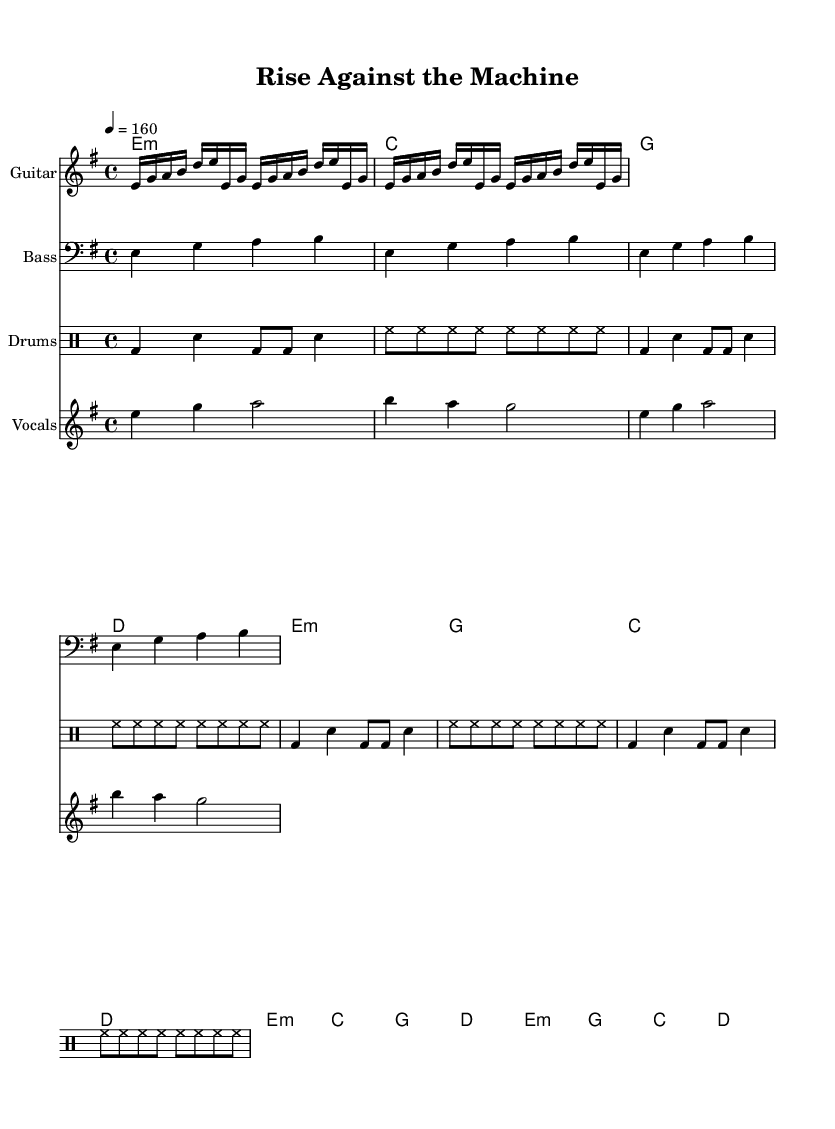What is the key signature of this music? The key signature is E minor, which has one sharp (F#). This is determined by looking at the two sharps listed in the key signature notation at the beginning of the music sheet.
Answer: E minor What is the time signature of this music? The time signature is 4/4, which is indicated at the beginning of the score. This means there are four beats per measure, and each quarter note gets one beat.
Answer: 4/4 What is the tempo marking of this music? The tempo marking is 160, shown on the score as "4 = 160". This indicates that there are 160 beats per minute, providing a fast-paced rhythm often found in punk music.
Answer: 160 How many measures does the guitar riff repeat? The guitar riff repeats four times, as indicated by the text `\repeat unfold 4` before the riff. This tells musicians to play that part in the score four times in a row.
Answer: 4 What style of music does this sheet represent? This sheet represents punk music, which is characterized by its fast tempo, simple chords, and often political themes. The references to both "Rise Against" and the political backdrop hint at its punk nature.
Answer: Punk Which instrument plays a bass clef? The instrument that plays a bass clef is the Bass, indicated by the notation `\clef "bass"` in the score. This clef is used for lower-pitched instruments.
Answer: Bass What type of harmony is indicated in the chord names? The harmony indicated in the chord names consists of minor and major chords, which include E minor and G major among others. This mixture of chords provides a distinct sound typical in punk anthems to convey emotion.
Answer: Minor and major chords 